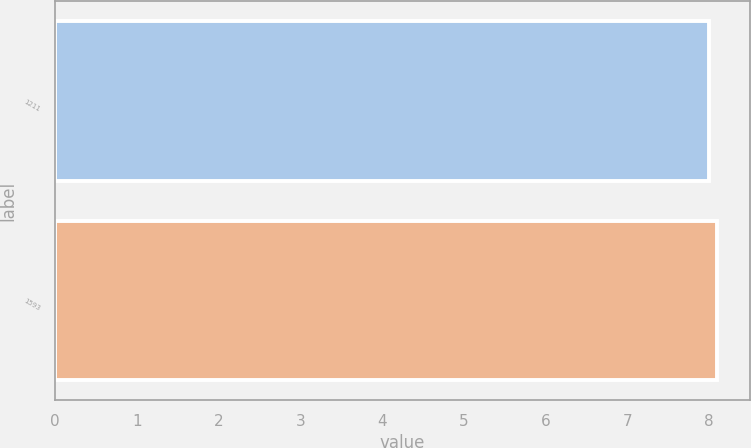<chart> <loc_0><loc_0><loc_500><loc_500><bar_chart><fcel>1211<fcel>1593<nl><fcel>8<fcel>8.1<nl></chart> 